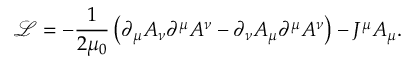<formula> <loc_0><loc_0><loc_500><loc_500>{ \mathcal { L } } = - { \frac { 1 } { 2 \mu _ { 0 } } } \left ( \partial _ { \mu } A _ { \nu } \partial ^ { \mu } A ^ { \nu } - \partial _ { \nu } A _ { \mu } \partial ^ { \mu } A ^ { \nu } \right ) - J ^ { \mu } A _ { \mu } .</formula> 